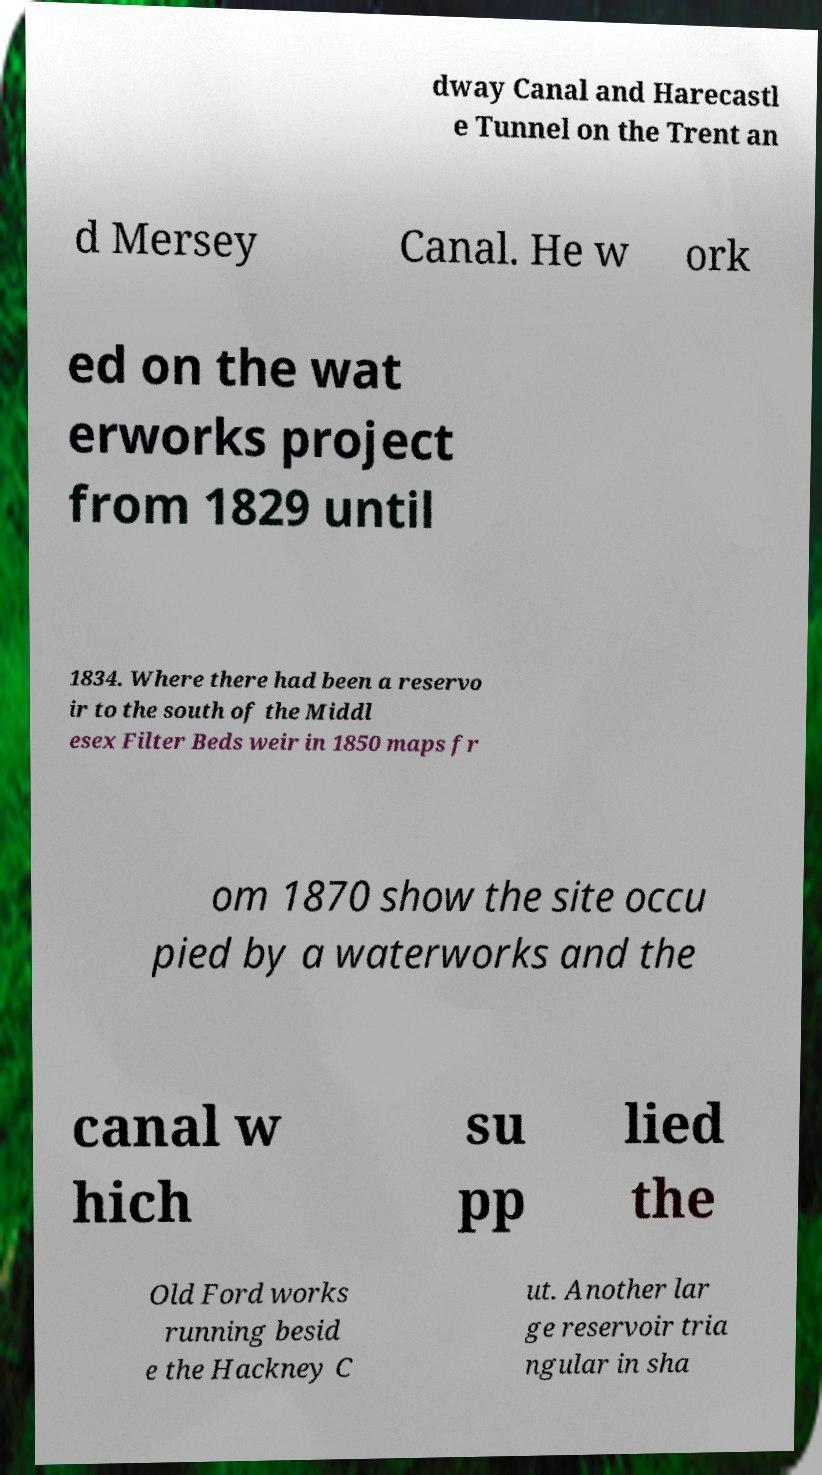Could you extract and type out the text from this image? dway Canal and Harecastl e Tunnel on the Trent an d Mersey Canal. He w ork ed on the wat erworks project from 1829 until 1834. Where there had been a reservo ir to the south of the Middl esex Filter Beds weir in 1850 maps fr om 1870 show the site occu pied by a waterworks and the canal w hich su pp lied the Old Ford works running besid e the Hackney C ut. Another lar ge reservoir tria ngular in sha 